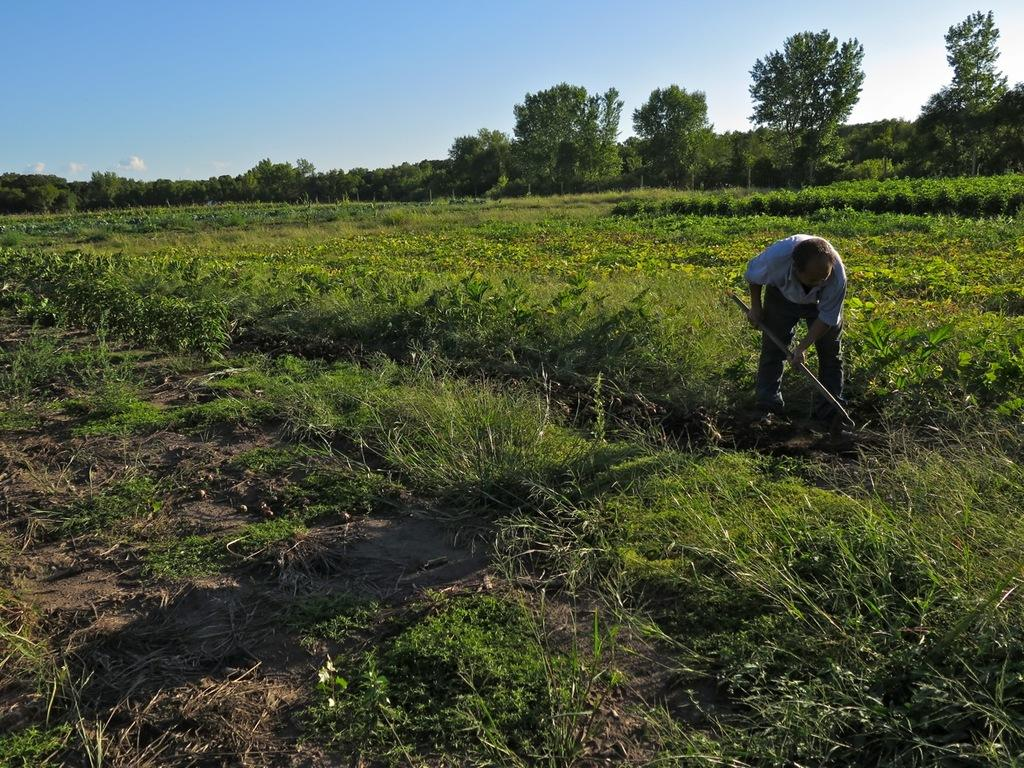What is present in the image? There is a man, plants, mud, trees, and the sky visible in the image. What is the man holding in his hands? The man is holding something in his hands, but the specific object is not mentioned in the facts. What type of vegetation can be seen in the image? There are plants and trees in the image. What is visible in the background of the image? Trees and the sky are visible in the background of the image. Can you see the man smiling in the image? The facts provided do not mention the man's expression, so it is not possible to determine if he is smiling or not. 